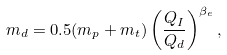<formula> <loc_0><loc_0><loc_500><loc_500>m _ { d } = 0 . 5 ( m _ { p } + m _ { t } ) \left ( \frac { Q _ { I } } { Q _ { d } } \right ) ^ { \beta _ { e } } ,</formula> 